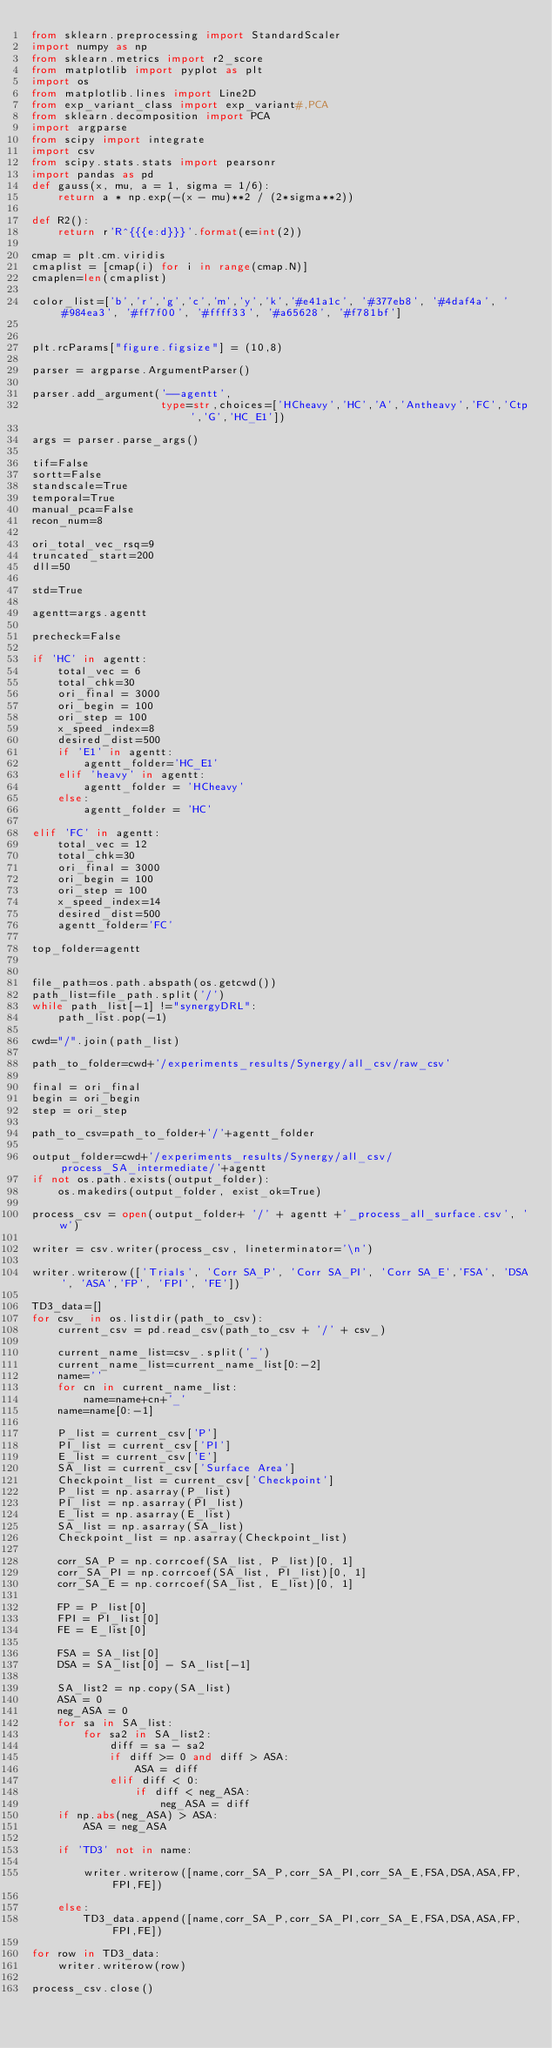Convert code to text. <code><loc_0><loc_0><loc_500><loc_500><_Python_>from sklearn.preprocessing import StandardScaler
import numpy as np
from sklearn.metrics import r2_score
from matplotlib import pyplot as plt
import os
from matplotlib.lines import Line2D
from exp_variant_class import exp_variant#,PCA
from sklearn.decomposition import PCA
import argparse
from scipy import integrate
import csv
from scipy.stats.stats import pearsonr
import pandas as pd
def gauss(x, mu, a = 1, sigma = 1/6):
    return a * np.exp(-(x - mu)**2 / (2*sigma**2))

def R2():
    return r'R^{{{e:d}}}'.format(e=int(2))

cmap = plt.cm.viridis
cmaplist = [cmap(i) for i in range(cmap.N)]
cmaplen=len(cmaplist)

color_list=['b','r','g','c','m','y','k','#e41a1c', '#377eb8', '#4daf4a', '#984ea3', '#ff7f00', '#ffff33', '#a65628', '#f781bf']


plt.rcParams["figure.figsize"] = (10,8)

parser = argparse.ArgumentParser()

parser.add_argument('--agentt',
                    type=str,choices=['HCheavy','HC','A','Antheavy','FC','Ctp','G','HC_E1'])

args = parser.parse_args()

tif=False
sortt=False
standscale=True
temporal=True
manual_pca=False
recon_num=8

ori_total_vec_rsq=9
truncated_start=200
dll=50

std=True

agentt=args.agentt

precheck=False

if 'HC' in agentt:
    total_vec = 6
    total_chk=30
    ori_final = 3000
    ori_begin = 100
    ori_step = 100
    x_speed_index=8
    desired_dist=500
    if 'E1' in agentt:
        agentt_folder='HC_E1'
    elif 'heavy' in agentt:
        agentt_folder = 'HCheavy'
    else:
        agentt_folder = 'HC'

elif 'FC' in agentt:
    total_vec = 12
    total_chk=30
    ori_final = 3000
    ori_begin = 100
    ori_step = 100
    x_speed_index=14
    desired_dist=500
    agentt_folder='FC'

top_folder=agentt


file_path=os.path.abspath(os.getcwd())
path_list=file_path.split('/')
while path_list[-1] !="synergyDRL":
    path_list.pop(-1)

cwd="/".join(path_list)

path_to_folder=cwd+'/experiments_results/Synergy/all_csv/raw_csv'

final = ori_final
begin = ori_begin
step = ori_step

path_to_csv=path_to_folder+'/'+agentt_folder

output_folder=cwd+'/experiments_results/Synergy/all_csv/process_SA_intermediate/'+agentt
if not os.path.exists(output_folder):
    os.makedirs(output_folder, exist_ok=True)

process_csv = open(output_folder+ '/' + agentt +'_process_all_surface.csv', 'w')

writer = csv.writer(process_csv, lineterminator='\n')

writer.writerow(['Trials', 'Corr SA_P', 'Corr SA_PI', 'Corr SA_E','FSA', 'DSA', 'ASA','FP', 'FPI', 'FE'])

TD3_data=[]
for csv_ in os.listdir(path_to_csv):
    current_csv = pd.read_csv(path_to_csv + '/' + csv_)

    current_name_list=csv_.split('_')
    current_name_list=current_name_list[0:-2]
    name=''
    for cn in current_name_list:
        name=name+cn+'_'
    name=name[0:-1]

    P_list = current_csv['P']
    PI_list = current_csv['PI']
    E_list = current_csv['E']
    SA_list = current_csv['Surface Area']
    Checkpoint_list = current_csv['Checkpoint']
    P_list = np.asarray(P_list)
    PI_list = np.asarray(PI_list)
    E_list = np.asarray(E_list)
    SA_list = np.asarray(SA_list)
    Checkpoint_list = np.asarray(Checkpoint_list)

    corr_SA_P = np.corrcoef(SA_list, P_list)[0, 1]
    corr_SA_PI = np.corrcoef(SA_list, PI_list)[0, 1]
    corr_SA_E = np.corrcoef(SA_list, E_list)[0, 1]

    FP = P_list[0]
    FPI = PI_list[0]
    FE = E_list[0]

    FSA = SA_list[0]
    DSA = SA_list[0] - SA_list[-1]

    SA_list2 = np.copy(SA_list)
    ASA = 0
    neg_ASA = 0
    for sa in SA_list:
        for sa2 in SA_list2:
            diff = sa - sa2
            if diff >= 0 and diff > ASA:
                ASA = diff
            elif diff < 0:
                if diff < neg_ASA:
                    neg_ASA = diff
    if np.abs(neg_ASA) > ASA:
        ASA = neg_ASA

    if 'TD3' not in name:

        writer.writerow([name,corr_SA_P,corr_SA_PI,corr_SA_E,FSA,DSA,ASA,FP,FPI,FE])

    else:
        TD3_data.append([name,corr_SA_P,corr_SA_PI,corr_SA_E,FSA,DSA,ASA,FP,FPI,FE])

for row in TD3_data:
    writer.writerow(row)

process_csv.close()


</code> 